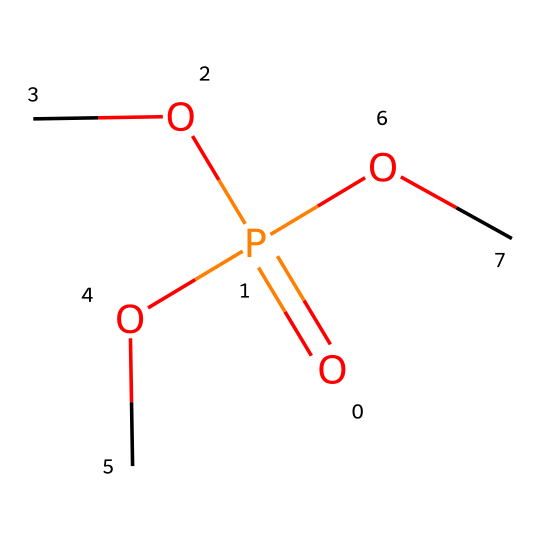What is the central atom in this compound? In the given SMILES representation, the phosphorus (P) is indicated as the central atom bonded to other groups. The presence of "O=P" shows that phosphorus is at the center of the chemical structure, and it is the main focus of this compound.
Answer: phosphorus How many oxygen atoms are in this molecule? By analyzing the SMILES notation, we can count the number of "O" present. There are four oxygen atoms in total attached to the phosphorus atom along with the "O=" indicating a double bond.
Answer: four What type of compound is this? The structure contains a phosphorus atom bonded to oxygen atoms, which classifies it as a phosphorus compound. Phosphorus compounds often include phosphorus with various elements like oxygen and carbon.
Answer: phosphorus compound What is the degree of saturation of the phosphorus atom? The phosphorus atom is connected to four groups (three alkoxy groups and one double-bonded oxygen), indicating it is fully saturated by these connections and doesn't have any lone pairs or additional bonds available.
Answer: saturated How many carbon atoms are attached to phosphorus in this compound? Review the structure; there are three "C" present in the SMILES, each corresponding to a carbon atom in the three methoxy (OC) groups attached to phosphorus.
Answer: three What functional groups are present in this structure? The primary functional group in the structure is the methoxy group (-OCH3) since there are three of them connected to the phosphorus, along with a phosphate group with one double bond to oxygen.
Answer: methoxy group What role does the phosphorus play in the glow stick's glow? In glow sticks, phosphorus compounds can facilitate chemical reactions that produce light; particularly, the phosphorus can serve as a source of energy and react with other components for luminescence.
Answer: energy source 